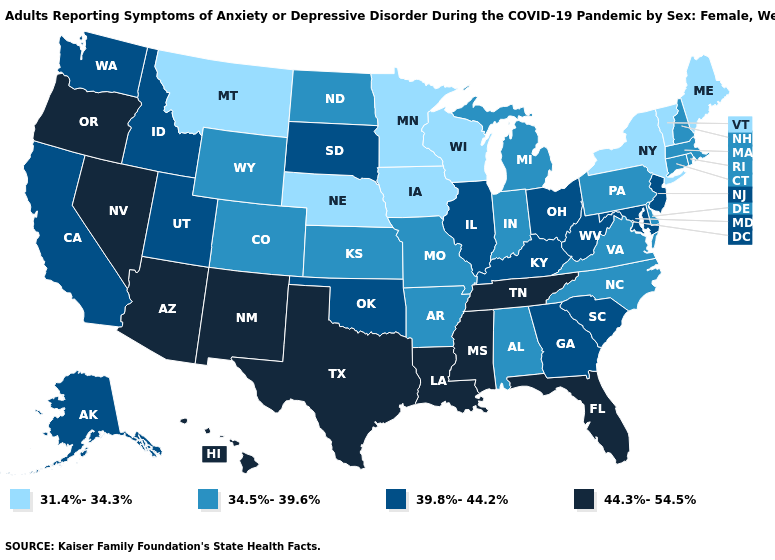How many symbols are there in the legend?
Be succinct. 4. Name the states that have a value in the range 34.5%-39.6%?
Keep it brief. Alabama, Arkansas, Colorado, Connecticut, Delaware, Indiana, Kansas, Massachusetts, Michigan, Missouri, New Hampshire, North Carolina, North Dakota, Pennsylvania, Rhode Island, Virginia, Wyoming. Does New Hampshire have the same value as Washington?
Quick response, please. No. Does Washington have the highest value in the USA?
Give a very brief answer. No. What is the value of Virginia?
Short answer required. 34.5%-39.6%. Which states have the lowest value in the Northeast?
Be succinct. Maine, New York, Vermont. What is the highest value in the USA?
Answer briefly. 44.3%-54.5%. Does the map have missing data?
Answer briefly. No. What is the value of Iowa?
Quick response, please. 31.4%-34.3%. Which states have the lowest value in the West?
Answer briefly. Montana. Which states have the highest value in the USA?
Be succinct. Arizona, Florida, Hawaii, Louisiana, Mississippi, Nevada, New Mexico, Oregon, Tennessee, Texas. What is the value of Colorado?
Quick response, please. 34.5%-39.6%. What is the value of Kentucky?
Keep it brief. 39.8%-44.2%. Does Pennsylvania have the same value as Arizona?
Answer briefly. No. Is the legend a continuous bar?
Write a very short answer. No. 